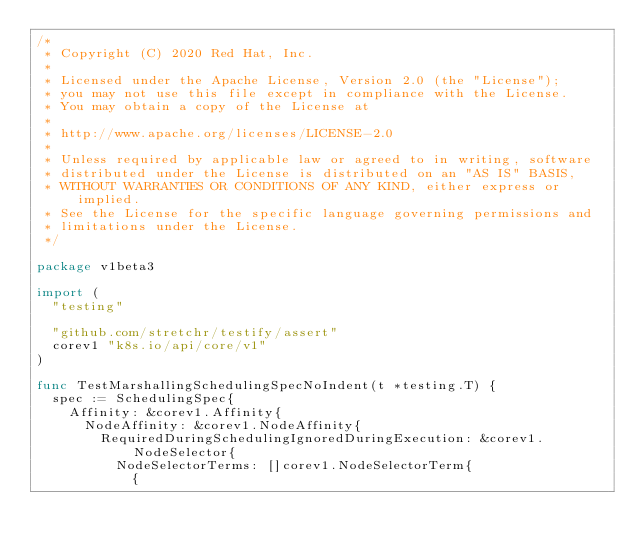Convert code to text. <code><loc_0><loc_0><loc_500><loc_500><_Go_>/*
 * Copyright (C) 2020 Red Hat, Inc.
 *
 * Licensed under the Apache License, Version 2.0 (the "License");
 * you may not use this file except in compliance with the License.
 * You may obtain a copy of the License at
 *
 * http://www.apache.org/licenses/LICENSE-2.0
 *
 * Unless required by applicable law or agreed to in writing, software
 * distributed under the License is distributed on an "AS IS" BASIS,
 * WITHOUT WARRANTIES OR CONDITIONS OF ANY KIND, either express or implied.
 * See the License for the specific language governing permissions and
 * limitations under the License.
 */

package v1beta3

import (
	"testing"

	"github.com/stretchr/testify/assert"
	corev1 "k8s.io/api/core/v1"
)

func TestMarshallingSchedulingSpecNoIndent(t *testing.T) {
	spec := SchedulingSpec{
		Affinity: &corev1.Affinity{
			NodeAffinity: &corev1.NodeAffinity{
				RequiredDuringSchedulingIgnoredDuringExecution: &corev1.NodeSelector{
					NodeSelectorTerms: []corev1.NodeSelectorTerm{
						{</code> 